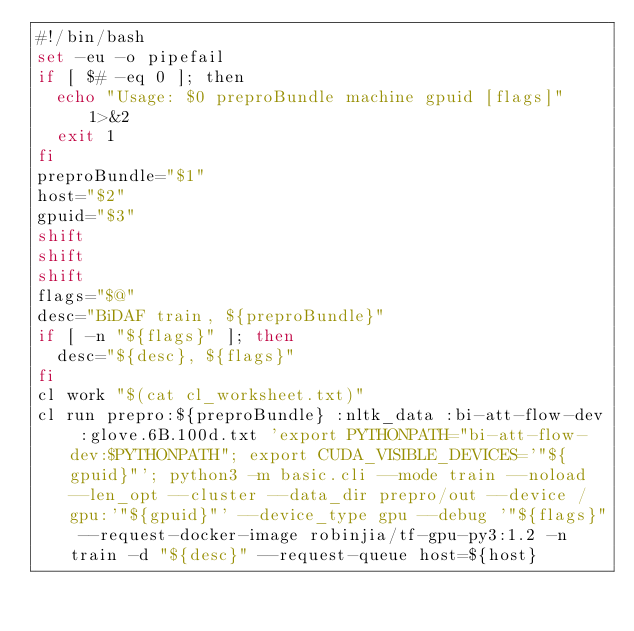Convert code to text. <code><loc_0><loc_0><loc_500><loc_500><_Bash_>#!/bin/bash
set -eu -o pipefail
if [ $# -eq 0 ]; then
  echo "Usage: $0 preproBundle machine gpuid [flags]" 1>&2
  exit 1
fi
preproBundle="$1"
host="$2"
gpuid="$3"
shift
shift
shift
flags="$@"
desc="BiDAF train, ${preproBundle}"
if [ -n "${flags}" ]; then
  desc="${desc}, ${flags}"
fi
cl work "$(cat cl_worksheet.txt)"
cl run prepro:${preproBundle} :nltk_data :bi-att-flow-dev :glove.6B.100d.txt 'export PYTHONPATH="bi-att-flow-dev:$PYTHONPATH"; export CUDA_VISIBLE_DEVICES='"${gpuid}"'; python3 -m basic.cli --mode train --noload --len_opt --cluster --data_dir prepro/out --device /gpu:'"${gpuid}"' --device_type gpu --debug '"${flags}" --request-docker-image robinjia/tf-gpu-py3:1.2 -n train -d "${desc}" --request-queue host=${host}

</code> 